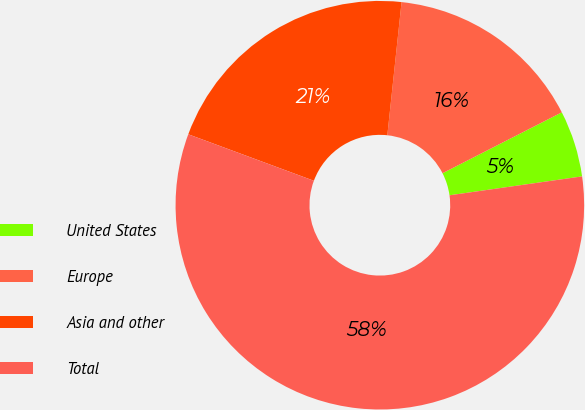Convert chart. <chart><loc_0><loc_0><loc_500><loc_500><pie_chart><fcel>United States<fcel>Europe<fcel>Asia and other<fcel>Total<nl><fcel>5.26%<fcel>15.79%<fcel>21.05%<fcel>57.89%<nl></chart> 